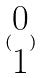<formula> <loc_0><loc_0><loc_500><loc_500>( \begin{matrix} 0 \\ 1 \end{matrix} )</formula> 